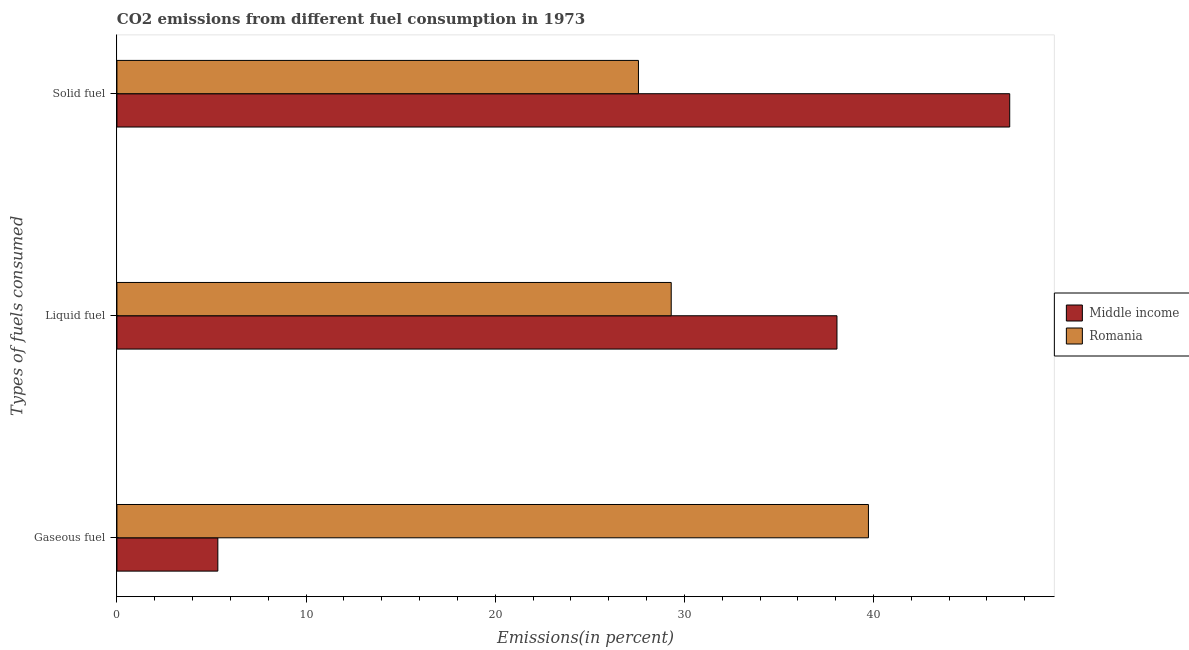How many groups of bars are there?
Keep it short and to the point. 3. Are the number of bars per tick equal to the number of legend labels?
Provide a succinct answer. Yes. How many bars are there on the 1st tick from the top?
Offer a terse response. 2. How many bars are there on the 1st tick from the bottom?
Offer a terse response. 2. What is the label of the 2nd group of bars from the top?
Offer a terse response. Liquid fuel. What is the percentage of gaseous fuel emission in Middle income?
Give a very brief answer. 5.34. Across all countries, what is the maximum percentage of liquid fuel emission?
Give a very brief answer. 38.07. Across all countries, what is the minimum percentage of solid fuel emission?
Ensure brevity in your answer.  27.57. In which country was the percentage of liquid fuel emission minimum?
Ensure brevity in your answer.  Romania. What is the total percentage of gaseous fuel emission in the graph?
Make the answer very short. 45.07. What is the difference between the percentage of gaseous fuel emission in Romania and that in Middle income?
Provide a short and direct response. 34.4. What is the difference between the percentage of liquid fuel emission in Romania and the percentage of solid fuel emission in Middle income?
Give a very brief answer. -17.9. What is the average percentage of solid fuel emission per country?
Provide a short and direct response. 37.39. What is the difference between the percentage of solid fuel emission and percentage of liquid fuel emission in Middle income?
Your answer should be very brief. 9.13. In how many countries, is the percentage of gaseous fuel emission greater than 26 %?
Make the answer very short. 1. What is the ratio of the percentage of solid fuel emission in Middle income to that in Romania?
Your answer should be very brief. 1.71. Is the percentage of liquid fuel emission in Middle income less than that in Romania?
Your answer should be very brief. No. Is the difference between the percentage of liquid fuel emission in Middle income and Romania greater than the difference between the percentage of gaseous fuel emission in Middle income and Romania?
Ensure brevity in your answer.  Yes. What is the difference between the highest and the second highest percentage of liquid fuel emission?
Make the answer very short. 8.76. What is the difference between the highest and the lowest percentage of gaseous fuel emission?
Offer a very short reply. 34.4. Is the sum of the percentage of solid fuel emission in Middle income and Romania greater than the maximum percentage of liquid fuel emission across all countries?
Your answer should be very brief. Yes. What does the 1st bar from the top in Liquid fuel represents?
Your response must be concise. Romania. What does the 2nd bar from the bottom in Gaseous fuel represents?
Your response must be concise. Romania. Is it the case that in every country, the sum of the percentage of gaseous fuel emission and percentage of liquid fuel emission is greater than the percentage of solid fuel emission?
Provide a short and direct response. No. How many bars are there?
Provide a succinct answer. 6. Are all the bars in the graph horizontal?
Provide a short and direct response. Yes. What is the difference between two consecutive major ticks on the X-axis?
Offer a terse response. 10. Are the values on the major ticks of X-axis written in scientific E-notation?
Give a very brief answer. No. Where does the legend appear in the graph?
Ensure brevity in your answer.  Center right. How many legend labels are there?
Offer a very short reply. 2. How are the legend labels stacked?
Offer a terse response. Vertical. What is the title of the graph?
Offer a terse response. CO2 emissions from different fuel consumption in 1973. What is the label or title of the X-axis?
Provide a succinct answer. Emissions(in percent). What is the label or title of the Y-axis?
Your answer should be compact. Types of fuels consumed. What is the Emissions(in percent) of Middle income in Gaseous fuel?
Give a very brief answer. 5.34. What is the Emissions(in percent) in Romania in Gaseous fuel?
Provide a short and direct response. 39.73. What is the Emissions(in percent) of Middle income in Liquid fuel?
Your answer should be compact. 38.07. What is the Emissions(in percent) in Romania in Liquid fuel?
Your answer should be very brief. 29.31. What is the Emissions(in percent) of Middle income in Solid fuel?
Make the answer very short. 47.2. What is the Emissions(in percent) in Romania in Solid fuel?
Give a very brief answer. 27.57. Across all Types of fuels consumed, what is the maximum Emissions(in percent) of Middle income?
Offer a very short reply. 47.2. Across all Types of fuels consumed, what is the maximum Emissions(in percent) of Romania?
Provide a short and direct response. 39.73. Across all Types of fuels consumed, what is the minimum Emissions(in percent) in Middle income?
Make the answer very short. 5.34. Across all Types of fuels consumed, what is the minimum Emissions(in percent) of Romania?
Give a very brief answer. 27.57. What is the total Emissions(in percent) of Middle income in the graph?
Your answer should be compact. 90.61. What is the total Emissions(in percent) in Romania in the graph?
Make the answer very short. 96.61. What is the difference between the Emissions(in percent) of Middle income in Gaseous fuel and that in Liquid fuel?
Offer a very short reply. -32.73. What is the difference between the Emissions(in percent) of Romania in Gaseous fuel and that in Liquid fuel?
Offer a terse response. 10.43. What is the difference between the Emissions(in percent) in Middle income in Gaseous fuel and that in Solid fuel?
Give a very brief answer. -41.87. What is the difference between the Emissions(in percent) of Romania in Gaseous fuel and that in Solid fuel?
Provide a short and direct response. 12.16. What is the difference between the Emissions(in percent) of Middle income in Liquid fuel and that in Solid fuel?
Make the answer very short. -9.13. What is the difference between the Emissions(in percent) of Romania in Liquid fuel and that in Solid fuel?
Your answer should be very brief. 1.73. What is the difference between the Emissions(in percent) in Middle income in Gaseous fuel and the Emissions(in percent) in Romania in Liquid fuel?
Provide a succinct answer. -23.97. What is the difference between the Emissions(in percent) of Middle income in Gaseous fuel and the Emissions(in percent) of Romania in Solid fuel?
Your answer should be compact. -22.24. What is the difference between the Emissions(in percent) in Middle income in Liquid fuel and the Emissions(in percent) in Romania in Solid fuel?
Provide a short and direct response. 10.5. What is the average Emissions(in percent) in Middle income per Types of fuels consumed?
Your answer should be very brief. 30.2. What is the average Emissions(in percent) in Romania per Types of fuels consumed?
Provide a succinct answer. 32.2. What is the difference between the Emissions(in percent) of Middle income and Emissions(in percent) of Romania in Gaseous fuel?
Give a very brief answer. -34.4. What is the difference between the Emissions(in percent) in Middle income and Emissions(in percent) in Romania in Liquid fuel?
Your answer should be compact. 8.76. What is the difference between the Emissions(in percent) in Middle income and Emissions(in percent) in Romania in Solid fuel?
Your answer should be compact. 19.63. What is the ratio of the Emissions(in percent) of Middle income in Gaseous fuel to that in Liquid fuel?
Give a very brief answer. 0.14. What is the ratio of the Emissions(in percent) of Romania in Gaseous fuel to that in Liquid fuel?
Your answer should be very brief. 1.36. What is the ratio of the Emissions(in percent) in Middle income in Gaseous fuel to that in Solid fuel?
Offer a very short reply. 0.11. What is the ratio of the Emissions(in percent) of Romania in Gaseous fuel to that in Solid fuel?
Ensure brevity in your answer.  1.44. What is the ratio of the Emissions(in percent) in Middle income in Liquid fuel to that in Solid fuel?
Provide a short and direct response. 0.81. What is the ratio of the Emissions(in percent) in Romania in Liquid fuel to that in Solid fuel?
Your answer should be very brief. 1.06. What is the difference between the highest and the second highest Emissions(in percent) of Middle income?
Your answer should be very brief. 9.13. What is the difference between the highest and the second highest Emissions(in percent) of Romania?
Keep it short and to the point. 10.43. What is the difference between the highest and the lowest Emissions(in percent) of Middle income?
Offer a terse response. 41.87. What is the difference between the highest and the lowest Emissions(in percent) in Romania?
Give a very brief answer. 12.16. 